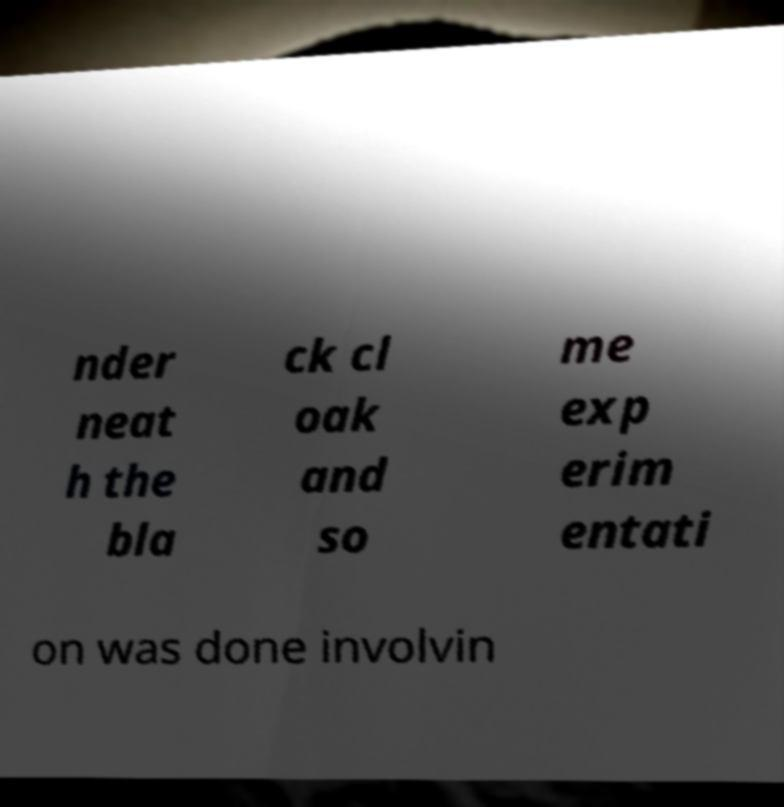Could you extract and type out the text from this image? nder neat h the bla ck cl oak and so me exp erim entati on was done involvin 